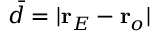<formula> <loc_0><loc_0><loc_500><loc_500>\bar { d } = | r _ { E } - r _ { o } |</formula> 